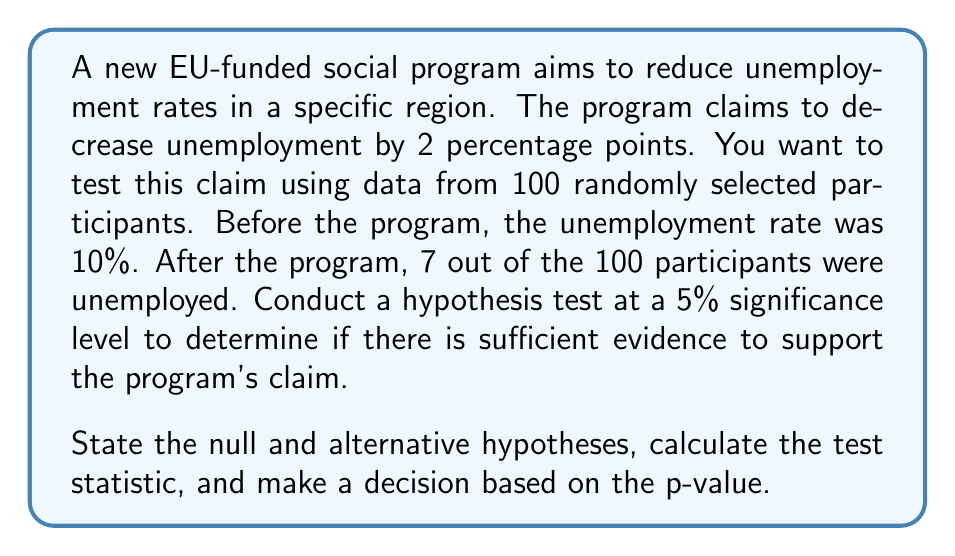What is the answer to this math problem? Step 1: State the hypotheses
Null hypothesis (H₀): p = 0.08 (2 percentage points less than the initial 10%)
Alternative hypothesis (H₁): p < 0.08 (The program reduces unemployment by more than 2 percentage points)

Step 2: Choose the significance level
α = 0.05 (given in the question)

Step 3: Calculate the test statistic
We use a one-sample z-test for proportions.

$z = \frac{\hat{p} - p_0}{\sqrt{\frac{p_0(1-p_0)}{n}}}$

Where:
$\hat{p}$ = sample proportion = 7/100 = 0.07
$p_0$ = hypothesized population proportion = 0.08
n = sample size = 100

$z = \frac{0.07 - 0.08}{\sqrt{\frac{0.08(1-0.08)}{100}}} = \frac{-0.01}{\sqrt{0.000736}} = -0.3689$

Step 4: Calculate the p-value
Using a standard normal distribution table or calculator:
p-value = P(Z < -0.3689) = 0.3561

Step 5: Make a decision
Since the p-value (0.3561) is greater than the significance level (0.05), we fail to reject the null hypothesis.

Step 6: Interpret the results
There is not sufficient evidence to conclude that the program reduces unemployment by more than 2 percentage points. The observed reduction could be due to chance rather than the effectiveness of the program.
Answer: Fail to reject H₀; insufficient evidence to support the program's claim (p-value = 0.3561 > 0.05). 